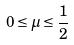Convert formula to latex. <formula><loc_0><loc_0><loc_500><loc_500>0 \leq \mu \leq \frac { 1 } { 2 }</formula> 